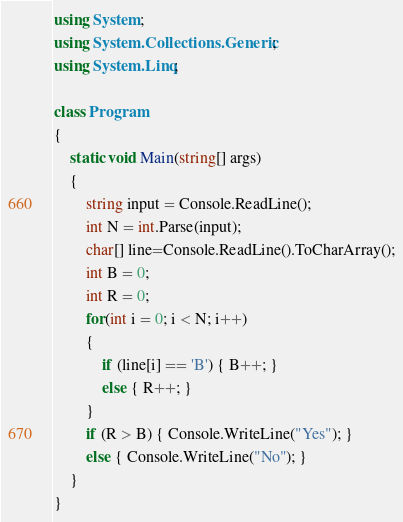<code> <loc_0><loc_0><loc_500><loc_500><_C#_>using System;
using System.Collections.Generic;
using System.Linq;

class Program
{
    static void Main(string[] args)
    {
        string input = Console.ReadLine();
        int N = int.Parse(input);
        char[] line=Console.ReadLine().ToCharArray();
        int B = 0;
        int R = 0;
        for(int i = 0; i < N; i++)
        {
            if (line[i] == 'B') { B++; }
            else { R++; }
        }
        if (R > B) { Console.WriteLine("Yes"); }
        else { Console.WriteLine("No"); }
    }
}

</code> 